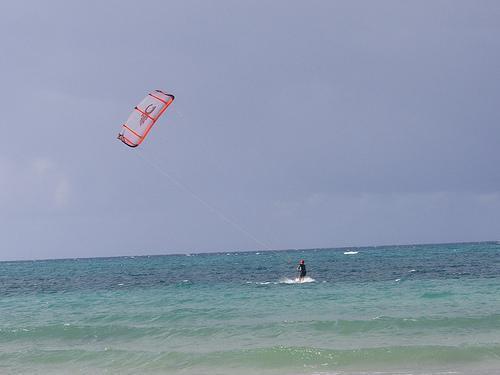How many people are there?
Give a very brief answer. 1. How many kites are in the sky?
Give a very brief answer. 1. 